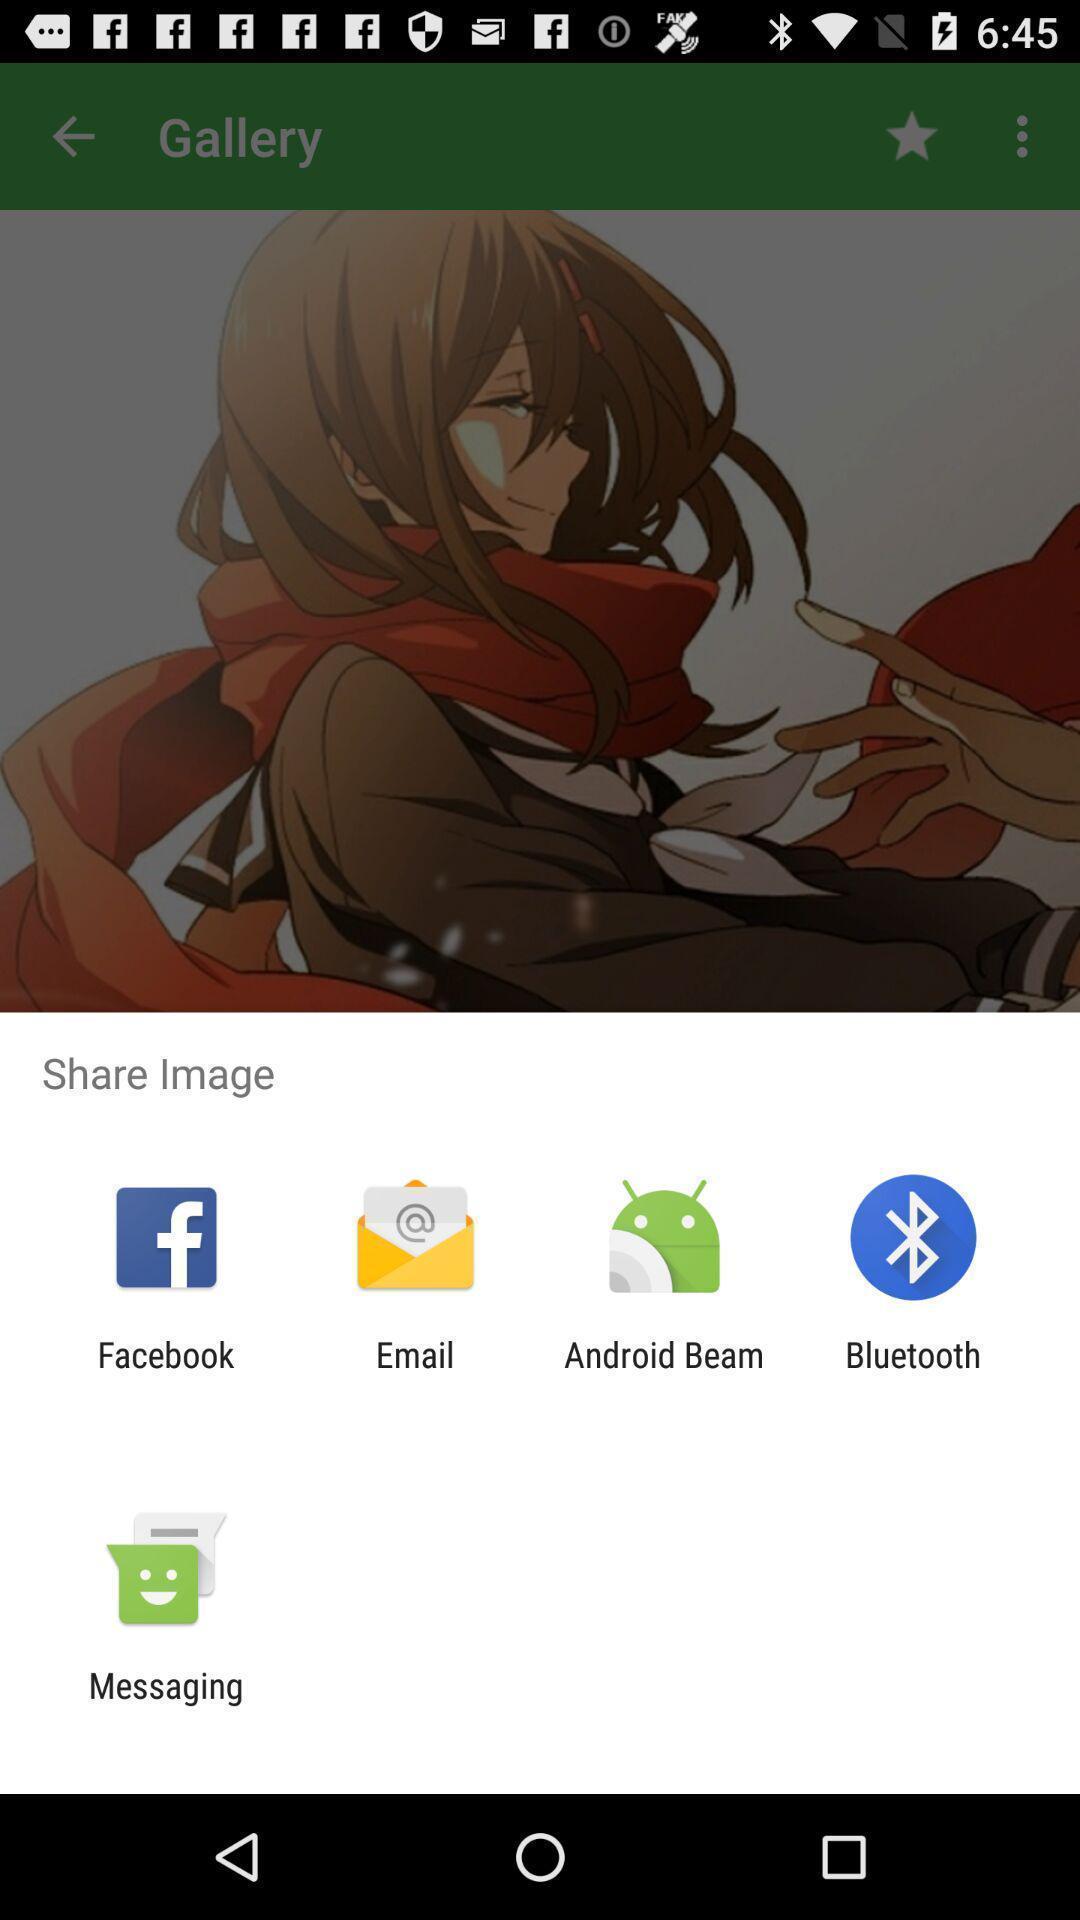Describe the visual elements of this screenshot. Widget showing multiple sharing applications. 